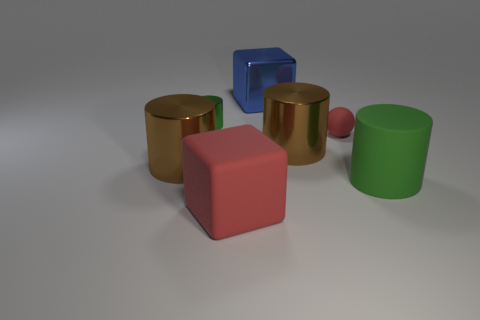Add 2 small purple rubber blocks. How many objects exist? 9 Subtract all blue blocks. How many blocks are left? 1 Subtract all green rubber cylinders. How many cylinders are left? 3 Subtract 1 blocks. How many blocks are left? 1 Subtract all red cubes. Subtract all red spheres. How many cubes are left? 1 Subtract all gray cylinders. How many brown blocks are left? 0 Subtract all red rubber cubes. Subtract all green rubber objects. How many objects are left? 5 Add 5 brown objects. How many brown objects are left? 7 Add 7 red rubber objects. How many red rubber objects exist? 9 Subtract 0 yellow cylinders. How many objects are left? 7 